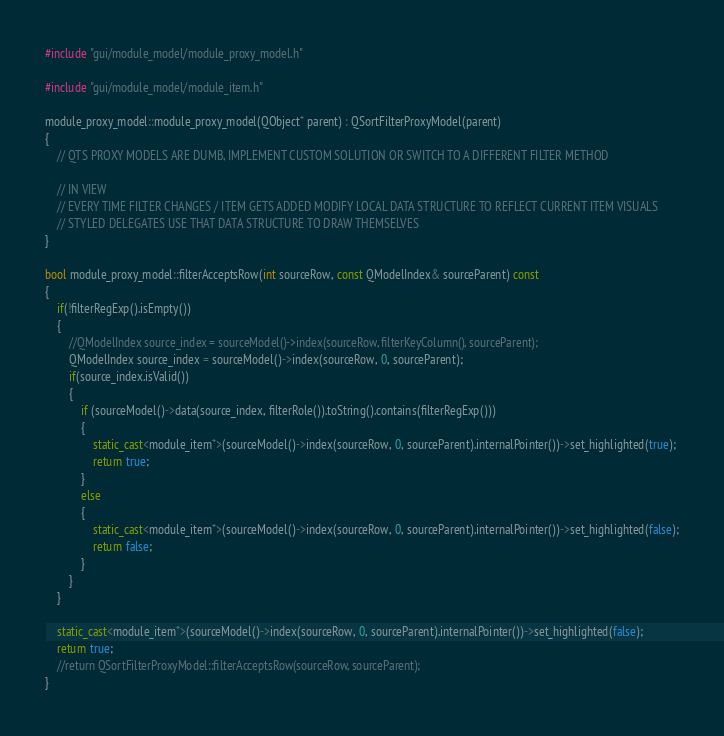<code> <loc_0><loc_0><loc_500><loc_500><_C++_>#include "gui/module_model/module_proxy_model.h"

#include "gui/module_model/module_item.h"

module_proxy_model::module_proxy_model(QObject* parent) : QSortFilterProxyModel(parent)
{
    // QTS PROXY MODELS ARE DUMB, IMPLEMENT CUSTOM SOLUTION OR SWITCH TO A DIFFERENT FILTER METHOD

    // IN VIEW
    // EVERY TIME FILTER CHANGES / ITEM GETS ADDED MODIFY LOCAL DATA STRUCTURE TO REFLECT CURRENT ITEM VISUALS
    // STYLED DELEGATES USE THAT DATA STRUCTURE TO DRAW THEMSELVES
}

bool module_proxy_model::filterAcceptsRow(int sourceRow, const QModelIndex& sourceParent) const
{
    if(!filterRegExp().isEmpty())
    {
        //QModelIndex source_index = sourceModel()->index(sourceRow, filterKeyColumn(), sourceParent);
        QModelIndex source_index = sourceModel()->index(sourceRow, 0, sourceParent);
        if(source_index.isValid())
        {
            if (sourceModel()->data(source_index, filterRole()).toString().contains(filterRegExp()))
            {
                static_cast<module_item*>(sourceModel()->index(sourceRow, 0, sourceParent).internalPointer())->set_highlighted(true);
                return true;
            }
            else
            {
                static_cast<module_item*>(sourceModel()->index(sourceRow, 0, sourceParent).internalPointer())->set_highlighted(false);
                return false;
            }
        }
    }

    static_cast<module_item*>(sourceModel()->index(sourceRow, 0, sourceParent).internalPointer())->set_highlighted(false);
    return true;
    //return QSortFilterProxyModel::filterAcceptsRow(sourceRow, sourceParent);
}
</code> 